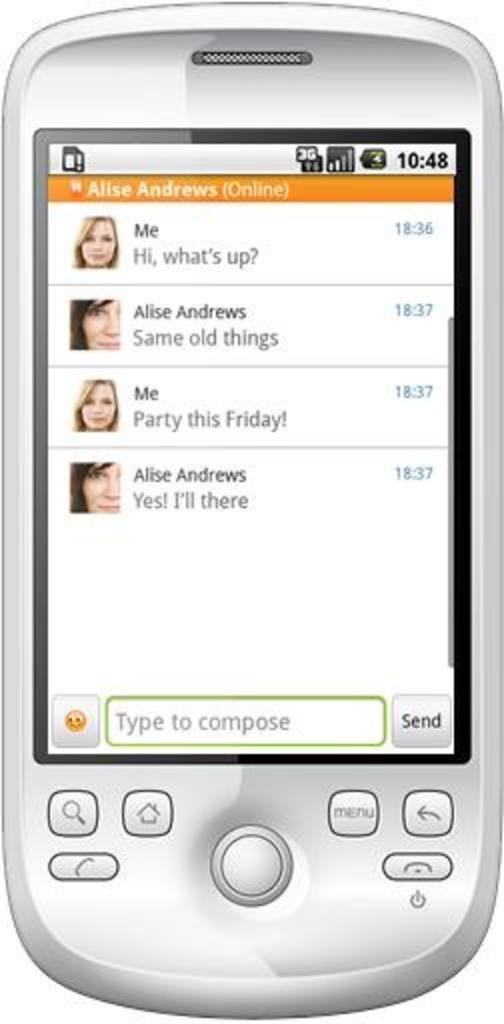<image>
Relay a brief, clear account of the picture shown. The woman on the text is inviting her friend to a party on Friday. 